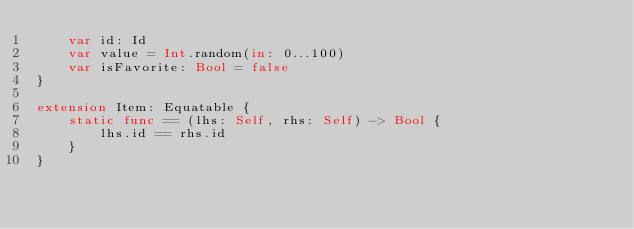<code> <loc_0><loc_0><loc_500><loc_500><_Swift_>    var id: Id
    var value = Int.random(in: 0...100)
    var isFavorite: Bool = false
}

extension Item: Equatable {
    static func == (lhs: Self, rhs: Self) -> Bool {
        lhs.id == rhs.id
    }
}
</code> 